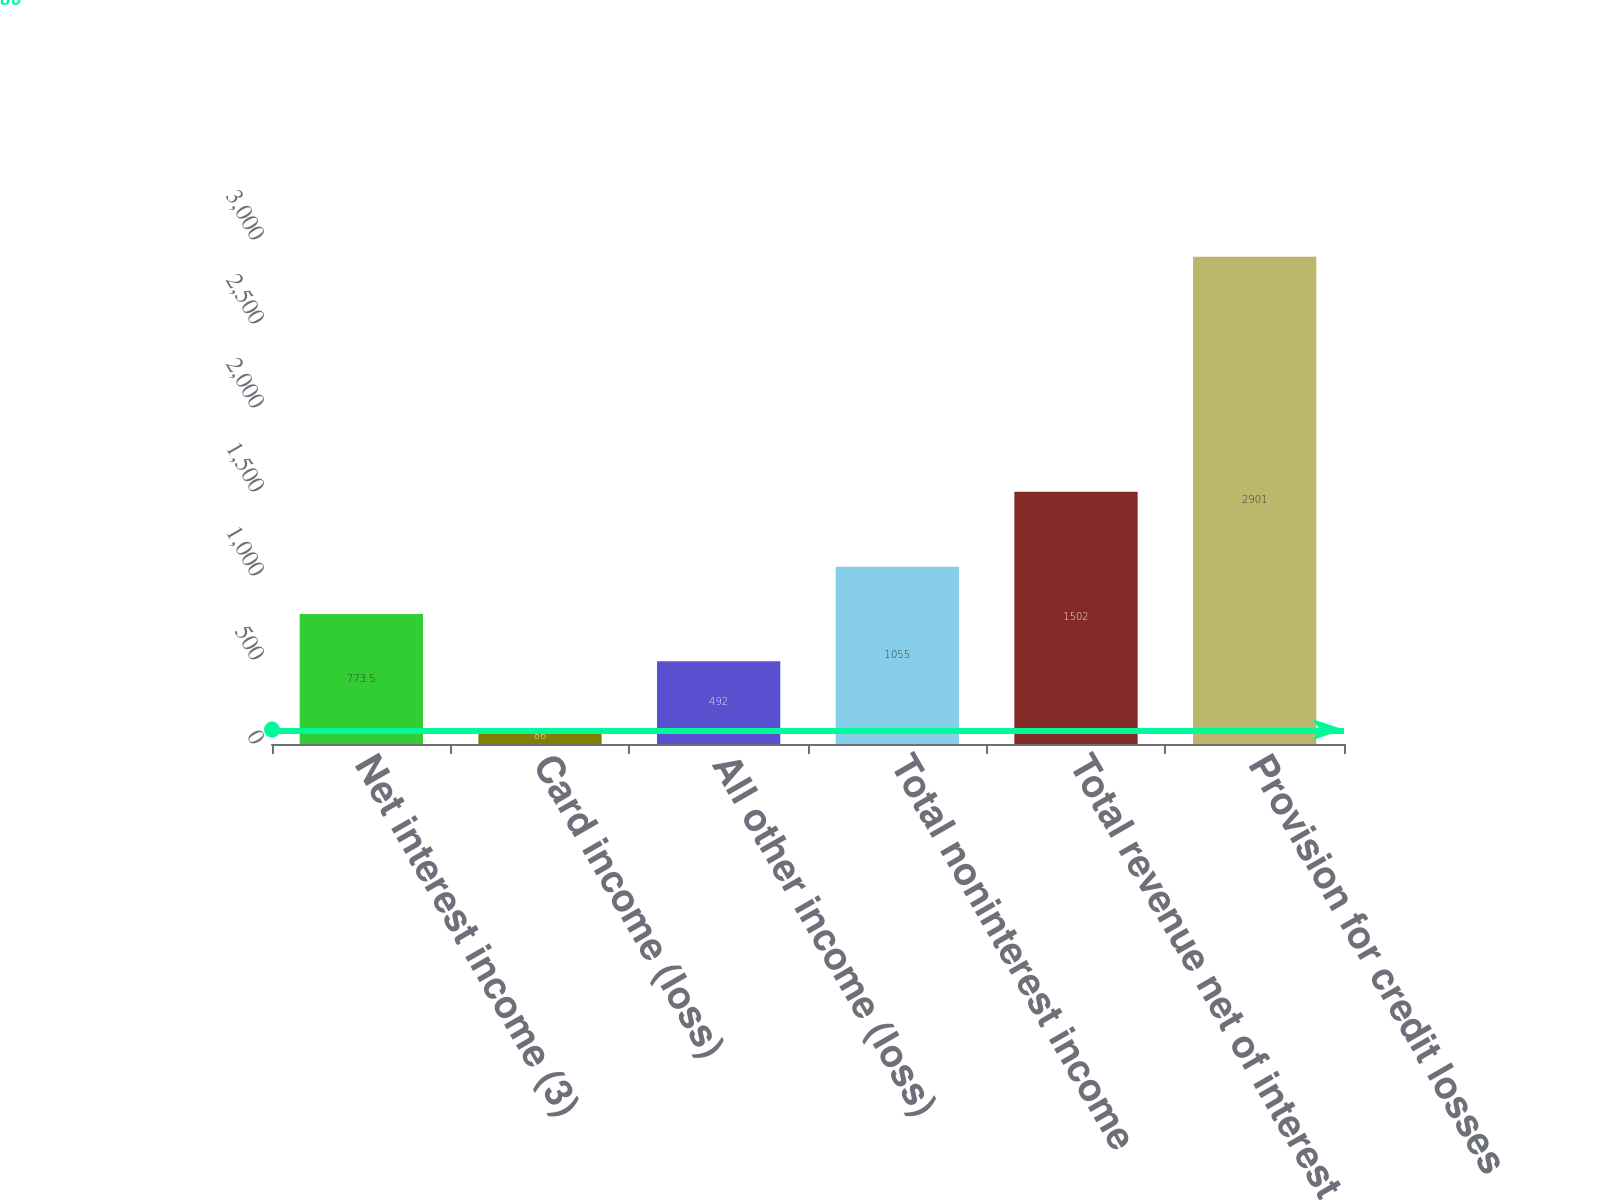<chart> <loc_0><loc_0><loc_500><loc_500><bar_chart><fcel>Net interest income (3)<fcel>Card income (loss)<fcel>All other income (loss)<fcel>Total noninterest income<fcel>Total revenue net of interest<fcel>Provision for credit losses<nl><fcel>773.5<fcel>86<fcel>492<fcel>1055<fcel>1502<fcel>2901<nl></chart> 